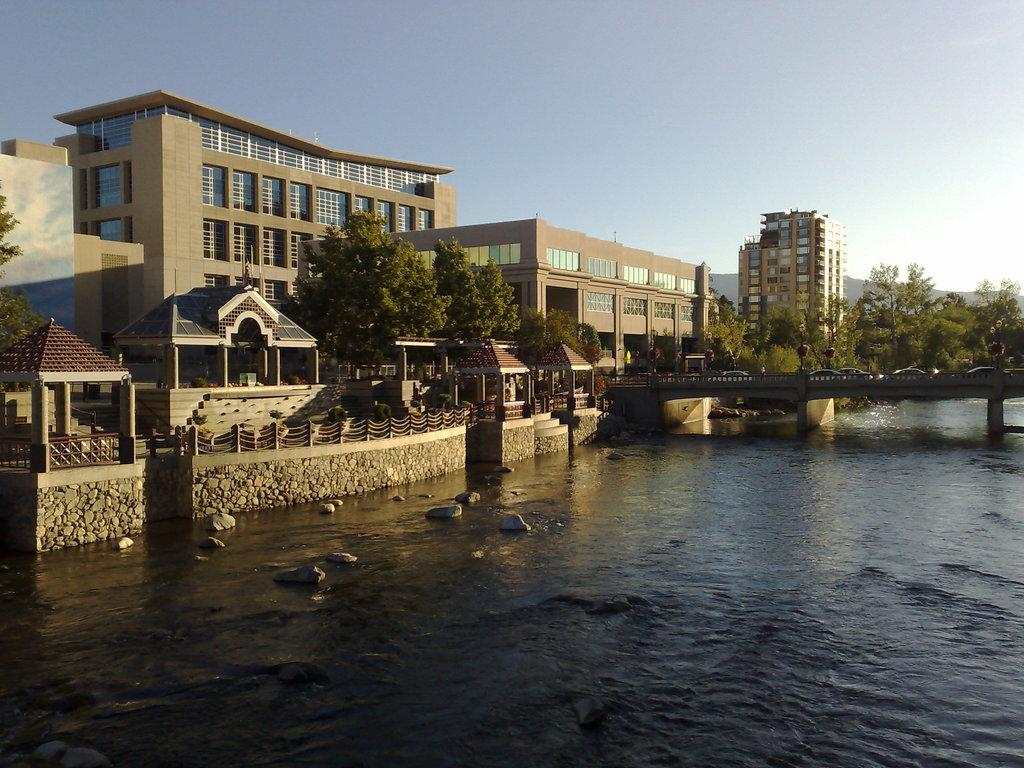What structure can be seen in the image? There is a bridge in the image. What is happening with the water in the image? Water is flowing in the image. What type of man-made structures are visible in the image? There are buildings in the image. What grade is the bike leaning against in the image? There is no bike present in the image, so it cannot be leaning against any grade. 